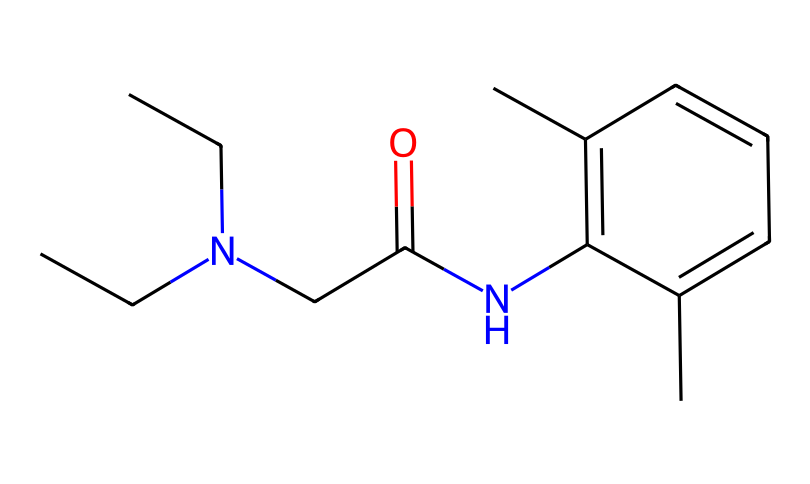What is the main functional group present in lidocaine? The main functional group in lidocaine is the amide group (C(=O)N). This can be identified by looking for the carbonyl (C=O) bonded to a nitrogen atom (N), which characterizes amides.
Answer: amide How many carbon atoms are present in the lidocaine structure? By analyzing the SMILES representation, we count the carbon (C) symbols to identify the total number of carbon atoms. There are a total of 14 carbon atoms in the structure.
Answer: 14 How many nitrogen atoms are present in lidocaine? From the SMILES representation, we can count the nitrogen (N) symbols to find the number of nitrogen atoms. In this chemical structure, there is one nitrogen atom.
Answer: 1 What type of compound is lidocaine classified as? Lidocaine is classified as a local anesthetic. This classification is based on its application as a medication to numb a specific area during minor procedures or injuries, such as those encountered in sports.
Answer: local anesthetic What is the molecular weight of lidocaine? To find the molecular weight, we consider the atomic weights of all the atoms in the structure (C, H, N, O), and sum them based on their count from the SMILES representation. The molecular weight is approximately 234.34 g/mol.
Answer: 234.34 g/mol What role does the carbonyl group play in the anesthetic properties of lidocaine? The carbonyl group (C=O) is involved in the stabilization of the molecule and is crucial for its interaction with nerve receptors, influencing its local anesthetic effect. This interaction affects how the drug blocks nerve signals.
Answer: stabilizing interaction How does the branching of carbon chains in lidocaine affect its solubility? The branching of carbon chains in lidocaine increases its hydrophobic character, which can influence its solubility in lipids, aiding in penetration into neural tissues for effective anesthetic action.
Answer: increases hydrophobicity 